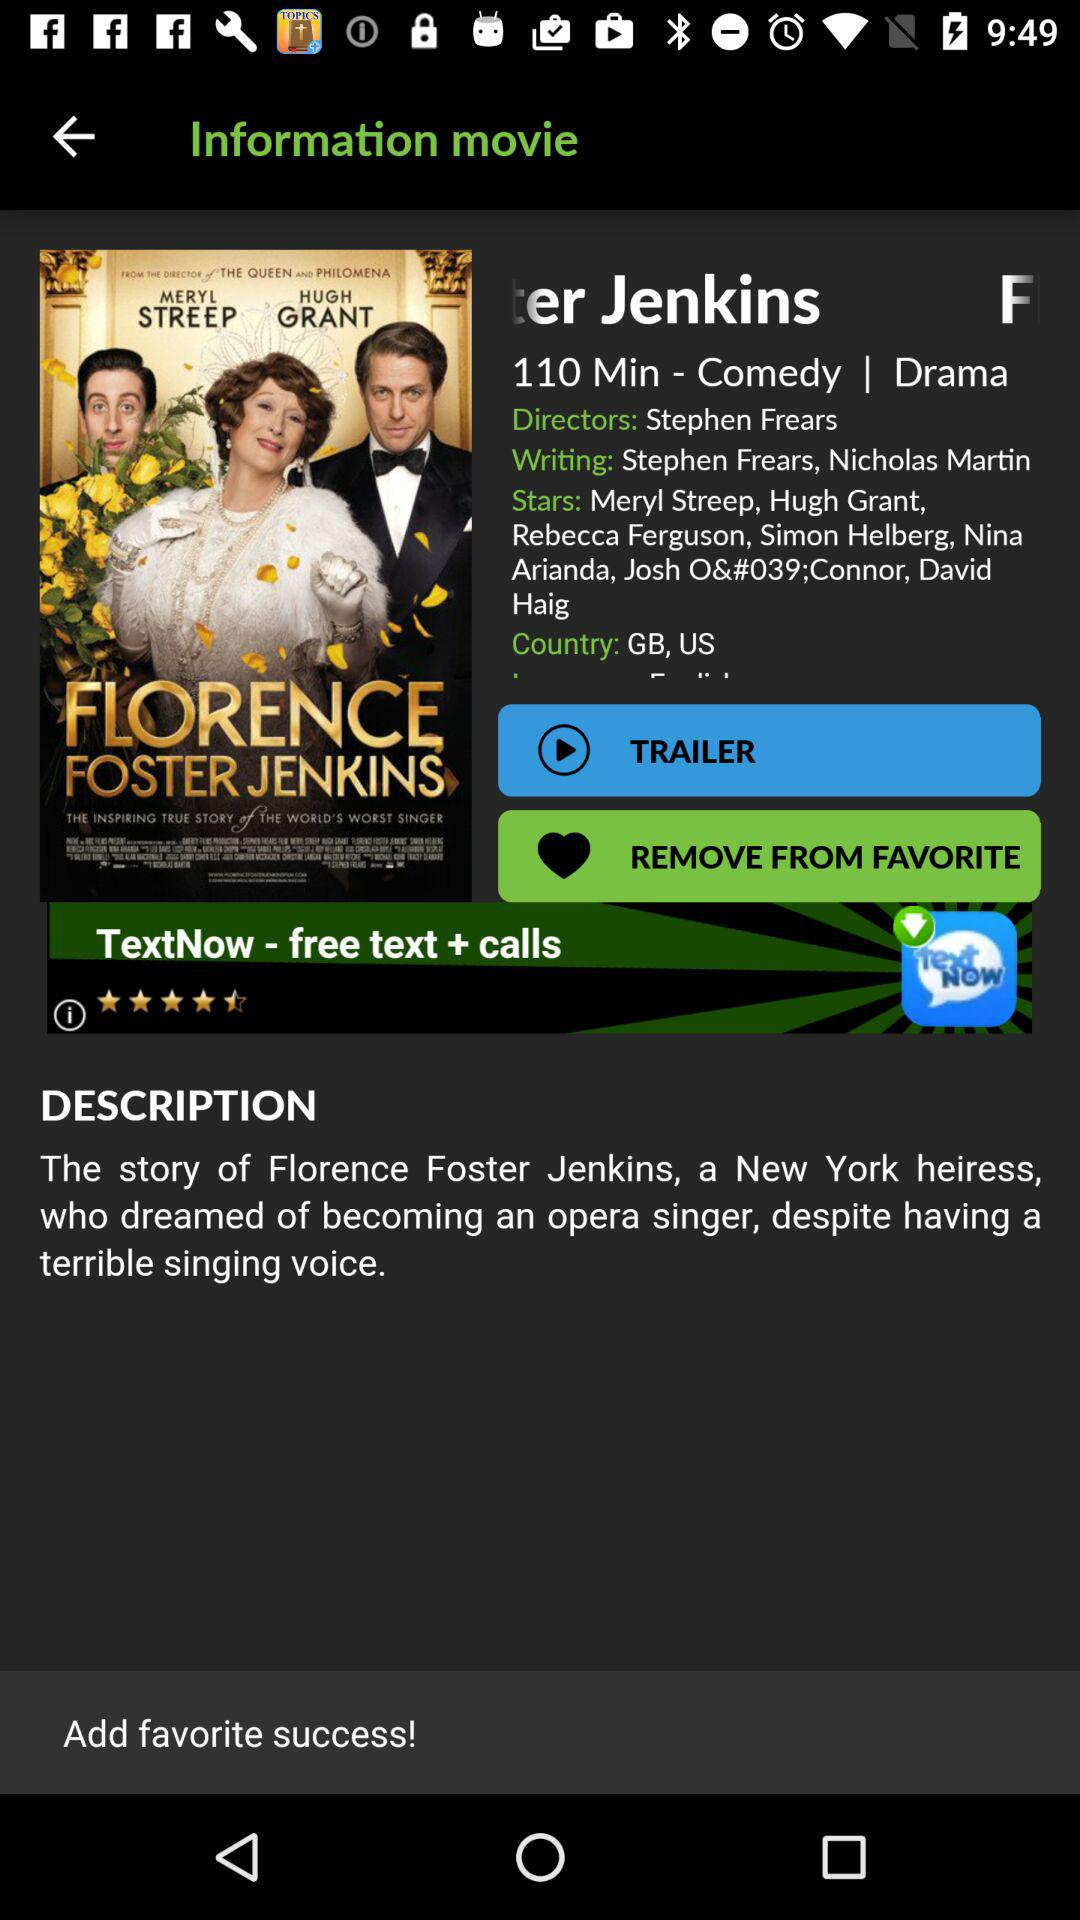What is the title of the movie? The title of the movie is "FLORENCE FOSTER JENKINS". 